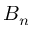<formula> <loc_0><loc_0><loc_500><loc_500>B _ { n }</formula> 